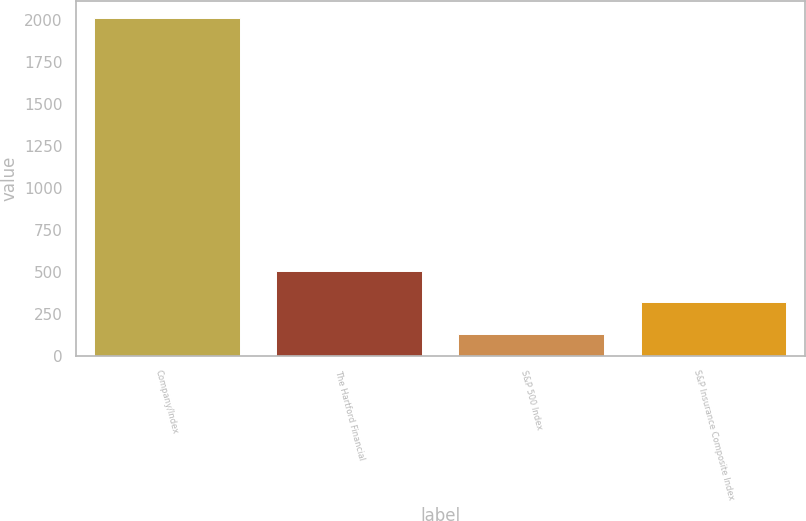Convert chart to OTSL. <chart><loc_0><loc_0><loc_500><loc_500><bar_chart><fcel>Company/Index<fcel>The Hartford Financial<fcel>S&P 500 Index<fcel>S&P Insurance Composite Index<nl><fcel>2016<fcel>506.45<fcel>129.05<fcel>317.75<nl></chart> 